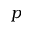Convert formula to latex. <formula><loc_0><loc_0><loc_500><loc_500>p</formula> 